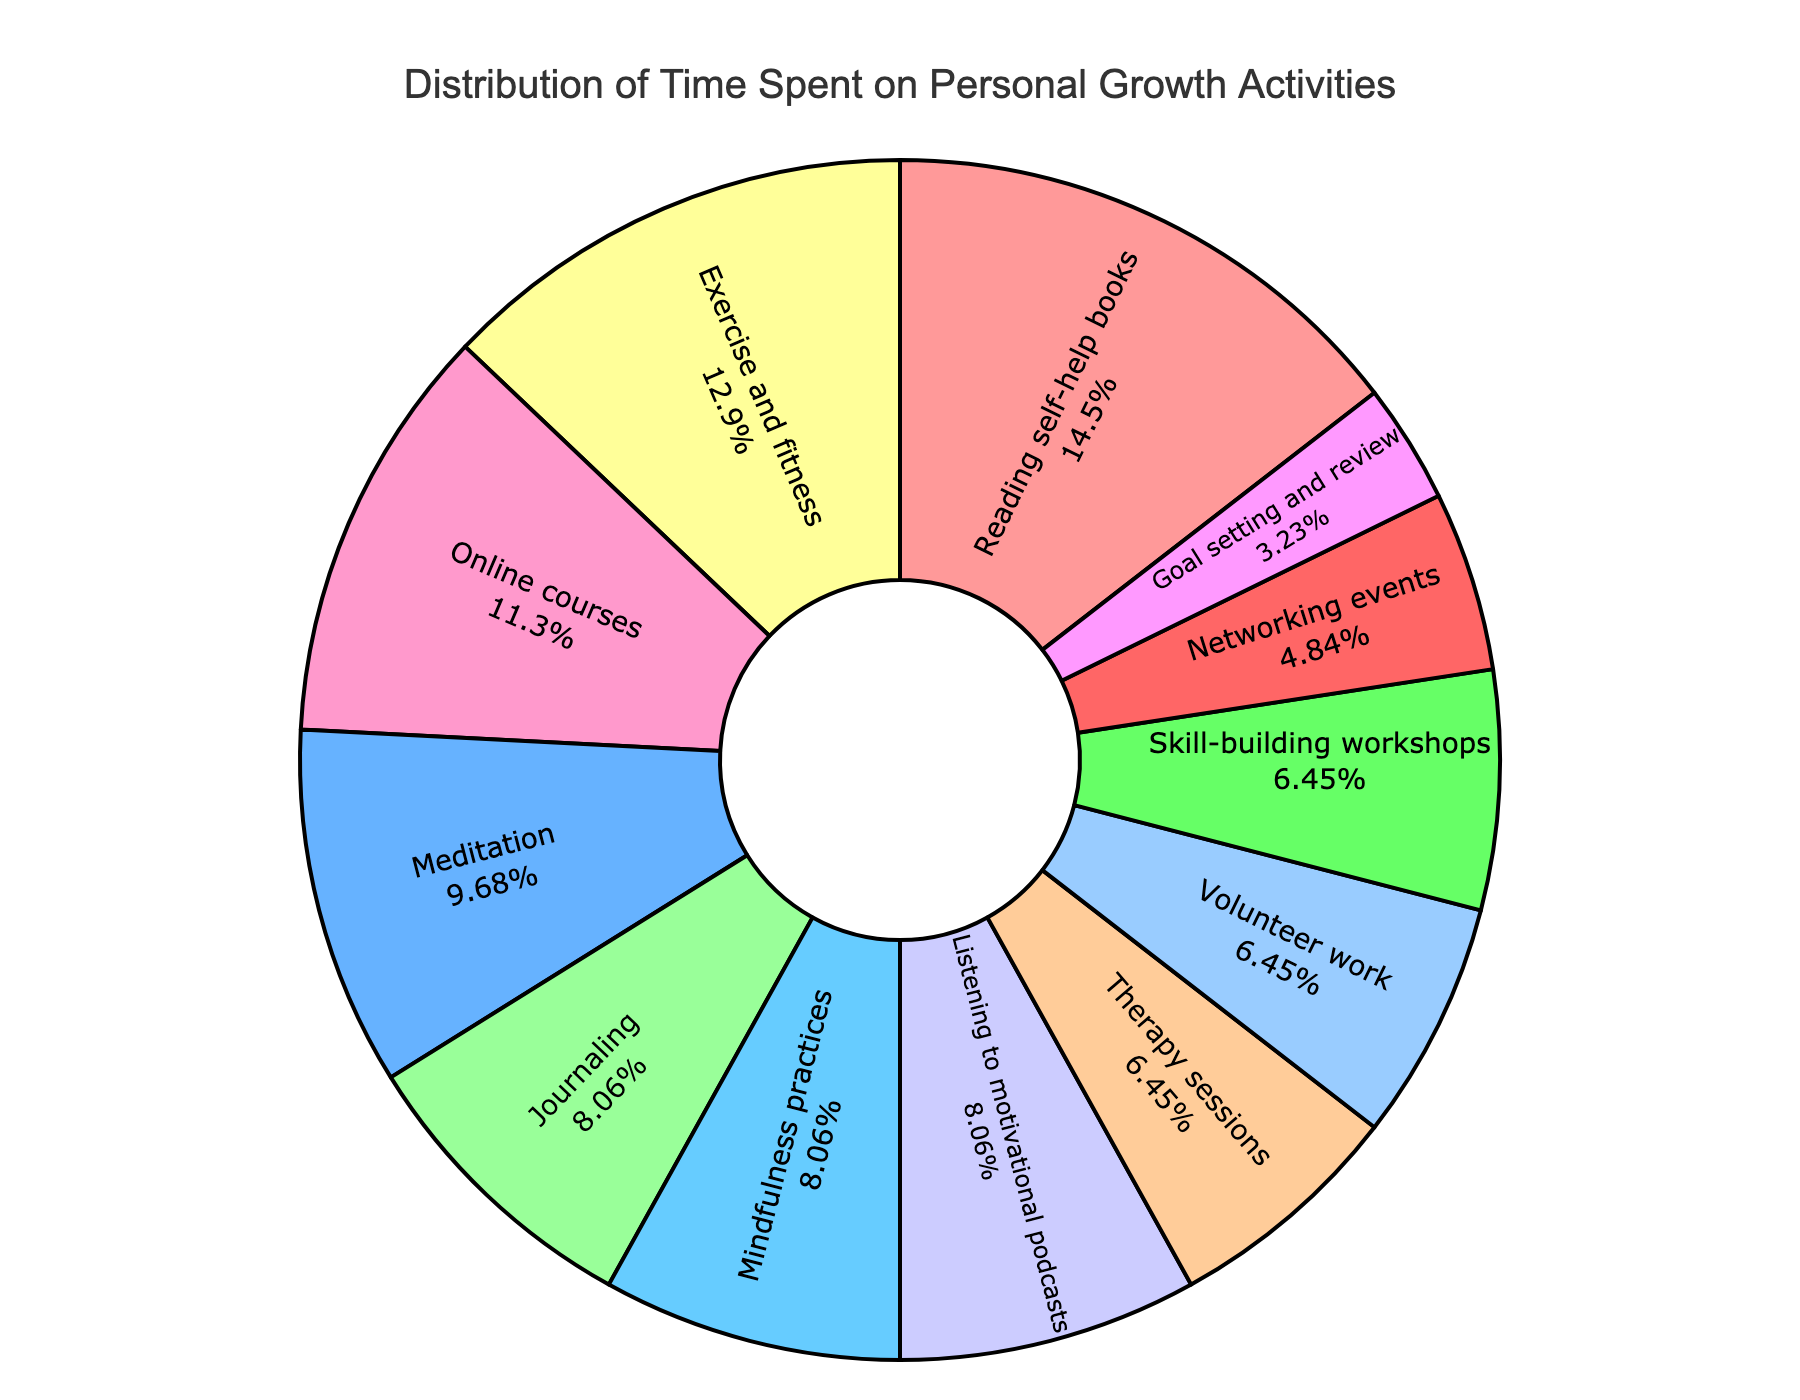Which activity takes up the most time? Identify the activity label with the largest percentage on the pie chart. The portion corresponding to Reading self-help books is the largest.
Answer: Reading self-help books What percentage of time is spent on Meditation and Online courses combined? Locate the sections for Meditation (3%) and Online courses (3.5%) and sum the percentages.
Answer: 6.5% Which activity occupies the smallest portion of the pie chart? Find the smallest segment, which is marked by the activity Goal setting and review.
Answer: Goal setting and review How much more time is spent on Exercise and fitness compared to Networking events? Compare the time for Exercise and fitness (4 hours) with Networking events (1.5 hours) and calculate the difference. 4 - 1.5 = 2.5 hours.
Answer: 2.5 hours What's the total time spent on all activities related to mindfulness (Meditation, Journaling, Mindfulness practices)? Add the hours spent on Meditation (3), Journaling (2.5), and Mindfulness practices (2.5). 3 + 2.5 + 2.5 = 8 hours.
Answer: 8 hours Which activity has a larger portion, Therapy sessions or Skill-building workshops? Compare the sizes of the segments for Therapy sessions and Skill-building workshops. Skill-building workshops is larger.
Answer: Skill-building workshops Are there any activities where the time spent is less than 2 hours per week? Identify any segment with a percentage indicating less than 2 hours. Networking events and Goal setting and review fit this criterion.
Answer: Yes What is the total time spent on activities labeled in green shades? Add the weekly hours for activities with green-marked segments (e.g., Meditation, Mindfulness practices). Verify individual green-labeled segments. Since we don't categorize all colors here, one needs to visually check if there is any green-shaded activity.
Answer: Not directly answerable without checking colors (context dependent) How does the time spent on Listening to motivational podcasts compare to Journaling? Compare the hours for Listening to motivational podcasts (2.5 hours) and Journaling (2.5 hours). Both are the same.
Answer: Equal 